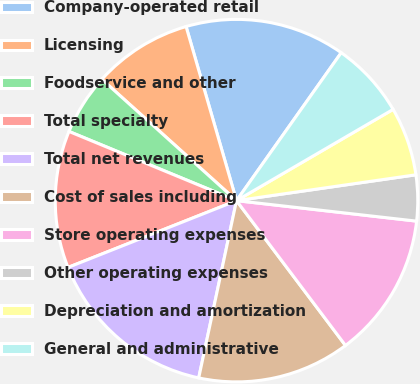Convert chart. <chart><loc_0><loc_0><loc_500><loc_500><pie_chart><fcel>Company-operated retail<fcel>Licensing<fcel>Foodservice and other<fcel>Total specialty<fcel>Total net revenues<fcel>Cost of sales including<fcel>Store operating expenses<fcel>Other operating expenses<fcel>Depreciation and amortization<fcel>General and administrative<nl><fcel>14.29%<fcel>8.84%<fcel>5.44%<fcel>12.24%<fcel>15.65%<fcel>13.61%<fcel>12.93%<fcel>4.08%<fcel>6.12%<fcel>6.8%<nl></chart> 